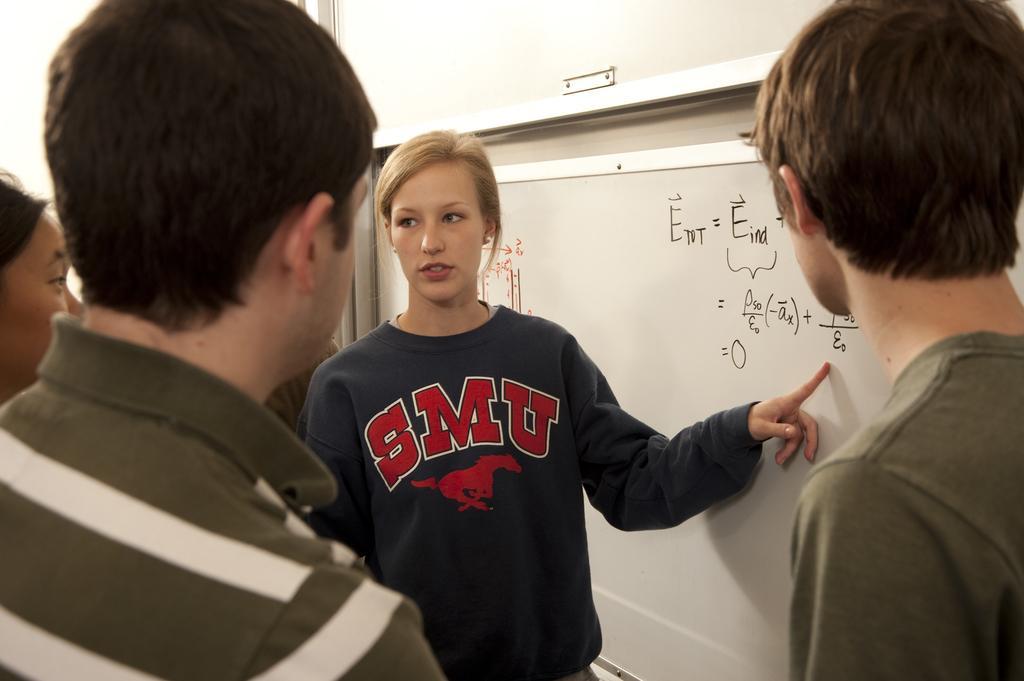In one or two sentences, can you explain what this image depicts? In this picture we can see a group of people standing and a woman is explaining something. On the right side of the people there is a white board and on the board it is written something. At the top of the whiteboard, it looks like a projector screen. 